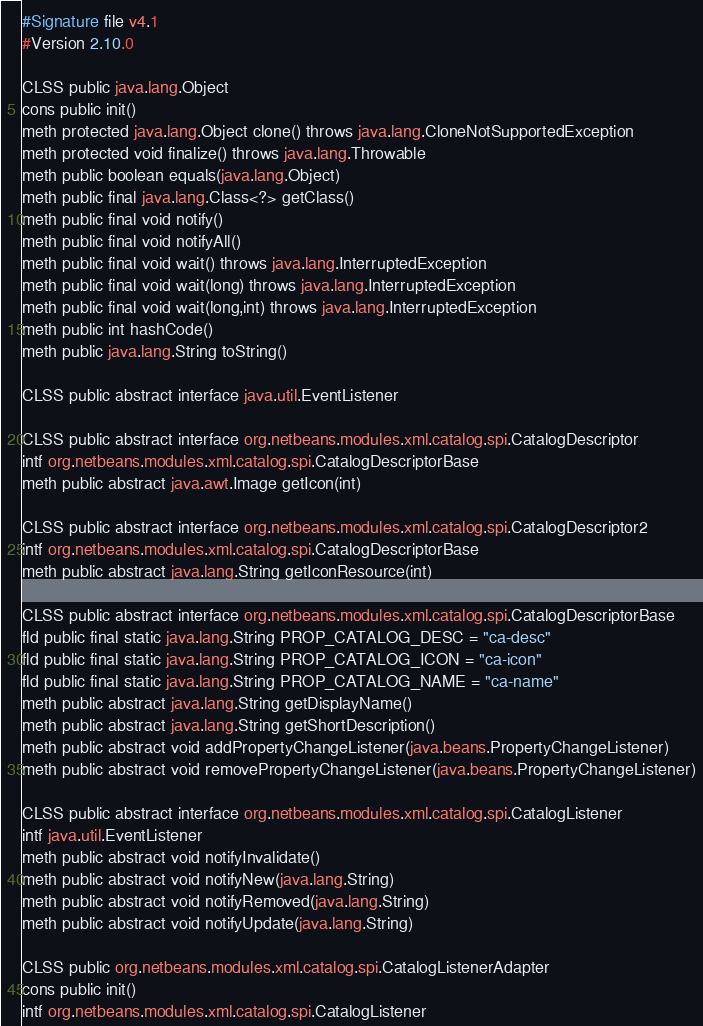Convert code to text. <code><loc_0><loc_0><loc_500><loc_500><_SML_>#Signature file v4.1
#Version 2.10.0

CLSS public java.lang.Object
cons public init()
meth protected java.lang.Object clone() throws java.lang.CloneNotSupportedException
meth protected void finalize() throws java.lang.Throwable
meth public boolean equals(java.lang.Object)
meth public final java.lang.Class<?> getClass()
meth public final void notify()
meth public final void notifyAll()
meth public final void wait() throws java.lang.InterruptedException
meth public final void wait(long) throws java.lang.InterruptedException
meth public final void wait(long,int) throws java.lang.InterruptedException
meth public int hashCode()
meth public java.lang.String toString()

CLSS public abstract interface java.util.EventListener

CLSS public abstract interface org.netbeans.modules.xml.catalog.spi.CatalogDescriptor
intf org.netbeans.modules.xml.catalog.spi.CatalogDescriptorBase
meth public abstract java.awt.Image getIcon(int)

CLSS public abstract interface org.netbeans.modules.xml.catalog.spi.CatalogDescriptor2
intf org.netbeans.modules.xml.catalog.spi.CatalogDescriptorBase
meth public abstract java.lang.String getIconResource(int)

CLSS public abstract interface org.netbeans.modules.xml.catalog.spi.CatalogDescriptorBase
fld public final static java.lang.String PROP_CATALOG_DESC = "ca-desc"
fld public final static java.lang.String PROP_CATALOG_ICON = "ca-icon"
fld public final static java.lang.String PROP_CATALOG_NAME = "ca-name"
meth public abstract java.lang.String getDisplayName()
meth public abstract java.lang.String getShortDescription()
meth public abstract void addPropertyChangeListener(java.beans.PropertyChangeListener)
meth public abstract void removePropertyChangeListener(java.beans.PropertyChangeListener)

CLSS public abstract interface org.netbeans.modules.xml.catalog.spi.CatalogListener
intf java.util.EventListener
meth public abstract void notifyInvalidate()
meth public abstract void notifyNew(java.lang.String)
meth public abstract void notifyRemoved(java.lang.String)
meth public abstract void notifyUpdate(java.lang.String)

CLSS public org.netbeans.modules.xml.catalog.spi.CatalogListenerAdapter
cons public init()
intf org.netbeans.modules.xml.catalog.spi.CatalogListener</code> 